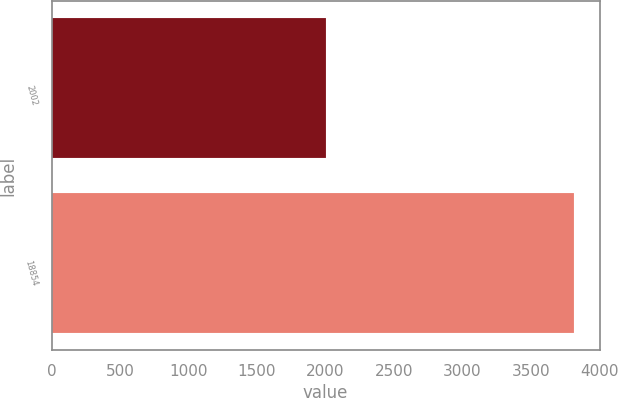Convert chart to OTSL. <chart><loc_0><loc_0><loc_500><loc_500><bar_chart><fcel>2002<fcel>18854<nl><fcel>2001<fcel>3812<nl></chart> 